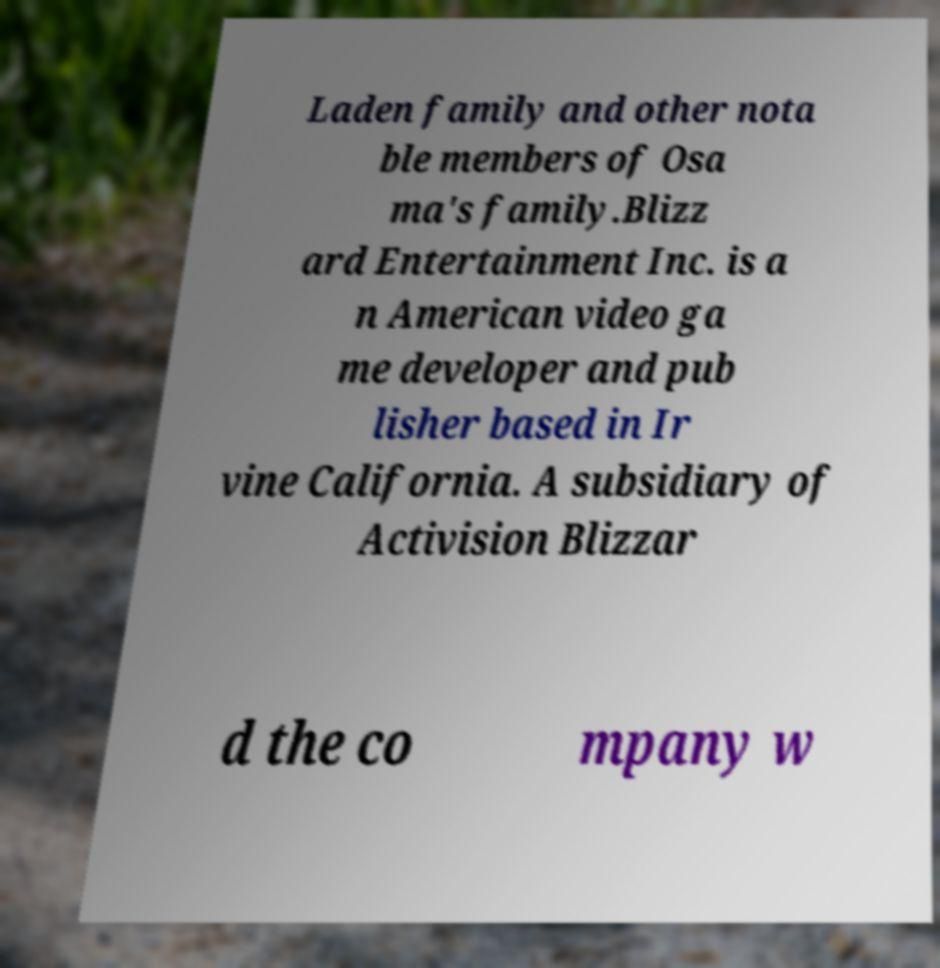For documentation purposes, I need the text within this image transcribed. Could you provide that? Laden family and other nota ble members of Osa ma's family.Blizz ard Entertainment Inc. is a n American video ga me developer and pub lisher based in Ir vine California. A subsidiary of Activision Blizzar d the co mpany w 